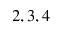<formula> <loc_0><loc_0><loc_500><loc_500>2 , 3 , 4</formula> 